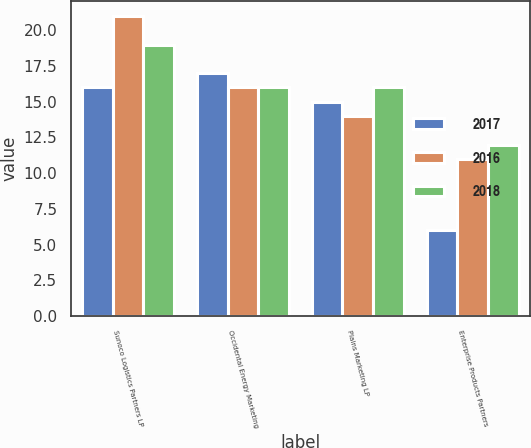Convert chart to OTSL. <chart><loc_0><loc_0><loc_500><loc_500><stacked_bar_chart><ecel><fcel>Sunoco Logistics Partners LP<fcel>Occidental Energy Marketing<fcel>Plains Marketing LP<fcel>Enterprise Products Partners<nl><fcel>2017<fcel>16<fcel>17<fcel>15<fcel>6<nl><fcel>2016<fcel>21<fcel>16<fcel>14<fcel>11<nl><fcel>2018<fcel>19<fcel>16<fcel>16<fcel>12<nl></chart> 